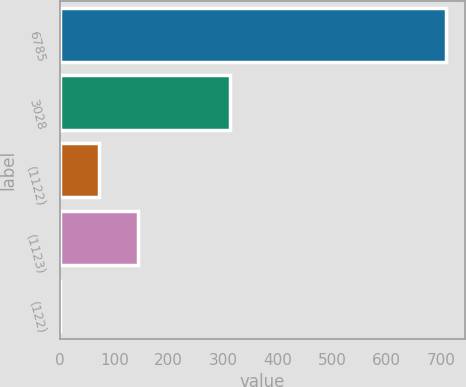Convert chart to OTSL. <chart><loc_0><loc_0><loc_500><loc_500><bar_chart><fcel>6785<fcel>3028<fcel>(1122)<fcel>(1123)<fcel>(122)<nl><fcel>709.1<fcel>313.6<fcel>72.5<fcel>143.33<fcel>0.79<nl></chart> 